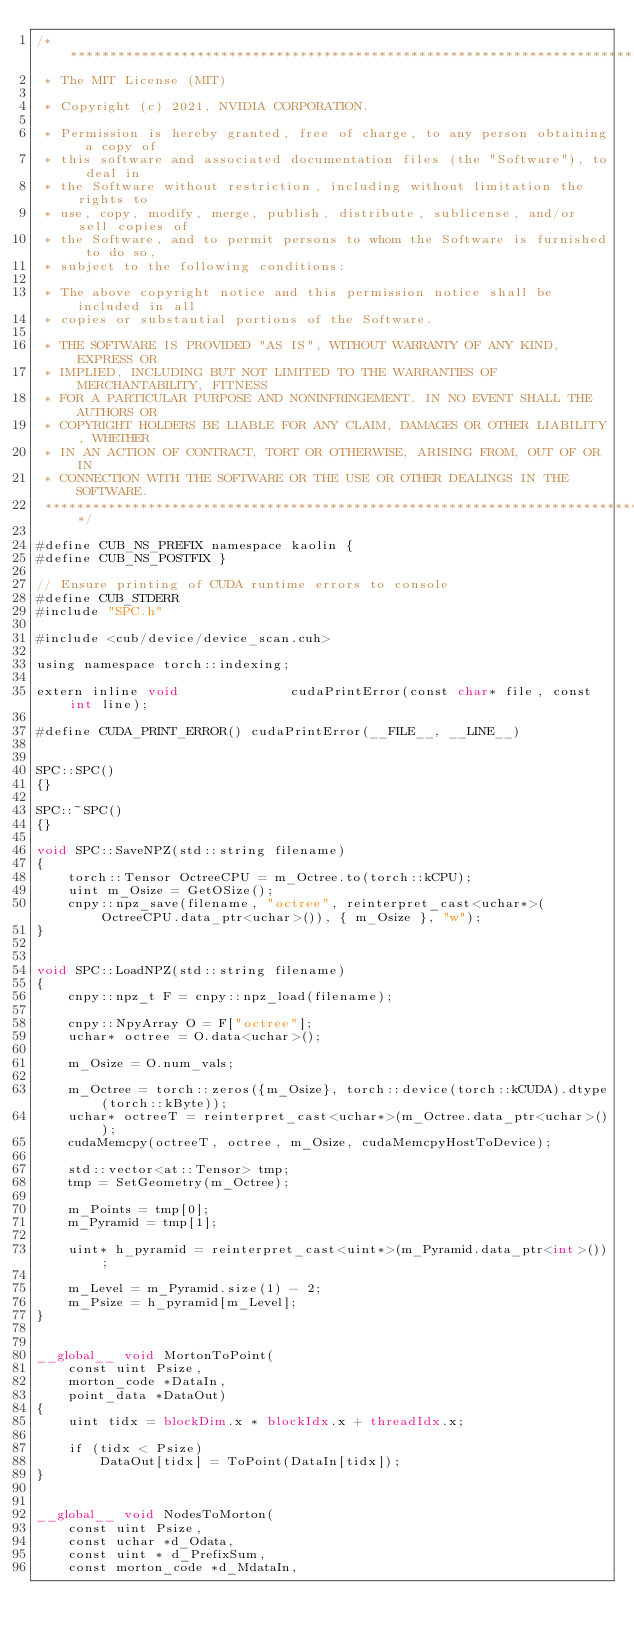<code> <loc_0><loc_0><loc_500><loc_500><_Cuda_>/******************************************************************************
 * The MIT License (MIT)

 * Copyright (c) 2021, NVIDIA CORPORATION.

 * Permission is hereby granted, free of charge, to any person obtaining a copy of
 * this software and associated documentation files (the "Software"), to deal in
 * the Software without restriction, including without limitation the rights to
 * use, copy, modify, merge, publish, distribute, sublicense, and/or sell copies of
 * the Software, and to permit persons to whom the Software is furnished to do so,
 * subject to the following conditions:

 * The above copyright notice and this permission notice shall be included in all
 * copies or substantial portions of the Software.

 * THE SOFTWARE IS PROVIDED "AS IS", WITHOUT WARRANTY OF ANY KIND, EXPRESS OR
 * IMPLIED, INCLUDING BUT NOT LIMITED TO THE WARRANTIES OF MERCHANTABILITY, FITNESS
 * FOR A PARTICULAR PURPOSE AND NONINFRINGEMENT. IN NO EVENT SHALL THE AUTHORS OR
 * COPYRIGHT HOLDERS BE LIABLE FOR ANY CLAIM, DAMAGES OR OTHER LIABILITY, WHETHER
 * IN AN ACTION OF CONTRACT, TORT OR OTHERWISE, ARISING FROM, OUT OF OR IN
 * CONNECTION WITH THE SOFTWARE OR THE USE OR OTHER DEALINGS IN THE SOFTWARE.
 ******************************************************************************/

#define CUB_NS_PREFIX namespace kaolin {
#define CUB_NS_POSTFIX }
    
// Ensure printing of CUDA runtime errors to console
#define CUB_STDERR
#include "SPC.h"

#include <cub/device/device_scan.cuh>

using namespace torch::indexing;  

extern inline void              cudaPrintError(const char* file, const int line);

#define CUDA_PRINT_ERROR() cudaPrintError(__FILE__, __LINE__)


SPC::SPC()
{}

SPC::~SPC()
{}

void SPC::SaveNPZ(std::string filename)
{
    torch::Tensor OctreeCPU = m_Octree.to(torch::kCPU);
    uint m_Osize = GetOSize();
    cnpy::npz_save(filename, "octree", reinterpret_cast<uchar*>(OctreeCPU.data_ptr<uchar>()), { m_Osize }, "w");
}
    

void SPC::LoadNPZ(std::string filename)
{
    cnpy::npz_t F = cnpy::npz_load(filename);

    cnpy::NpyArray O = F["octree"];
    uchar* octree = O.data<uchar>();
    
    m_Osize = O.num_vals;

    m_Octree = torch::zeros({m_Osize}, torch::device(torch::kCUDA).dtype(torch::kByte));
    uchar* octreeT = reinterpret_cast<uchar*>(m_Octree.data_ptr<uchar>());
    cudaMemcpy(octreeT, octree, m_Osize, cudaMemcpyHostToDevice);

    std::vector<at::Tensor> tmp;   
    tmp = SetGeometry(m_Octree);

    m_Points = tmp[0];
    m_Pyramid = tmp[1];

    uint* h_pyramid = reinterpret_cast<uint*>(m_Pyramid.data_ptr<int>());
   
    m_Level = m_Pyramid.size(1) - 2;
    m_Psize = h_pyramid[m_Level];
}
    
        
__global__ void MortonToPoint(
    const uint Psize,
    morton_code *DataIn,
    point_data *DataOut)
{
    uint tidx = blockDim.x * blockIdx.x + threadIdx.x;

    if (tidx < Psize)
        DataOut[tidx] = ToPoint(DataIn[tidx]);
}


__global__ void NodesToMorton(
    const uint Psize,
    const uchar *d_Odata,
    const uint * d_PrefixSum,
    const morton_code *d_MdataIn,</code> 